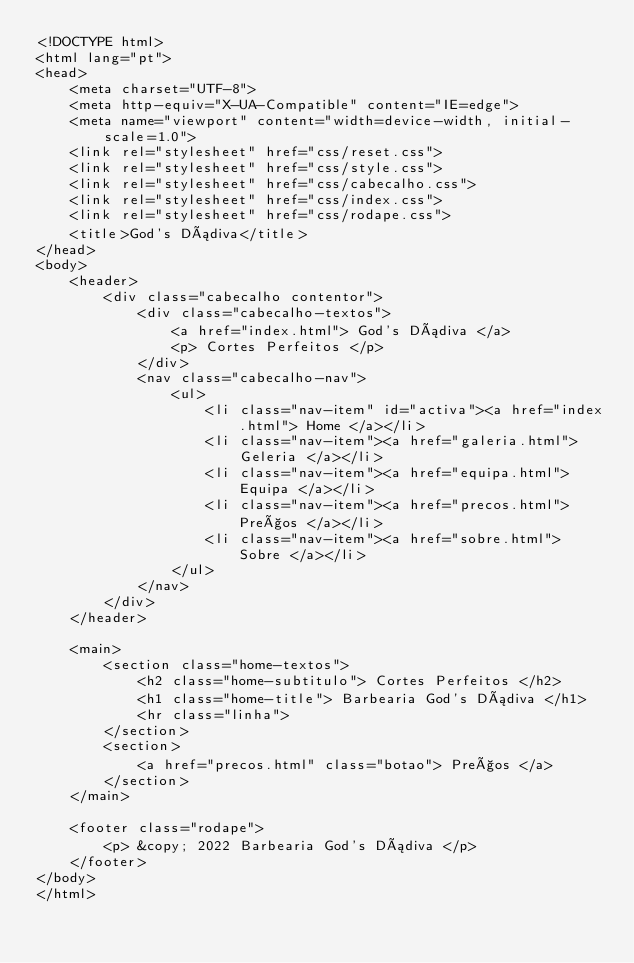Convert code to text. <code><loc_0><loc_0><loc_500><loc_500><_HTML_><!DOCTYPE html>
<html lang="pt">
<head>
    <meta charset="UTF-8">
    <meta http-equiv="X-UA-Compatible" content="IE=edge">
    <meta name="viewport" content="width=device-width, initial-scale=1.0">
    <link rel="stylesheet" href="css/reset.css">
    <link rel="stylesheet" href="css/style.css">
    <link rel="stylesheet" href="css/cabecalho.css">
    <link rel="stylesheet" href="css/index.css">
    <link rel="stylesheet" href="css/rodape.css">
    <title>God's Dádiva</title>
</head>
<body>
    <header>
        <div class="cabecalho contentor">
            <div class="cabecalho-textos">
                <a href="index.html"> God's Dádiva </a>
                <p> Cortes Perfeitos </p>
            </div>
            <nav class="cabecalho-nav">
                <ul>
                    <li class="nav-item" id="activa"><a href="index.html"> Home </a></li>
                    <li class="nav-item"><a href="galeria.html"> Geleria </a></li>
                    <li class="nav-item"><a href="equipa.html"> Equipa </a></li>
                    <li class="nav-item"><a href="precos.html"> Preços </a></li>
                    <li class="nav-item"><a href="sobre.html"> Sobre </a></li>
                </ul>
            </nav>
        </div>
    </header>
    
    <main>
        <section class="home-textos">
            <h2 class="home-subtitulo"> Cortes Perfeitos </h2>
            <h1 class="home-title"> Barbearia God's Dádiva </h1>
            <hr class="linha">
        </section>
        <section>
            <a href="precos.html" class="botao"> Preços </a>
        </section>
    </main>

    <footer class="rodape">
        <p> &copy; 2022 Barbearia God's Dádiva </p>
    </footer>
</body>
</html></code> 